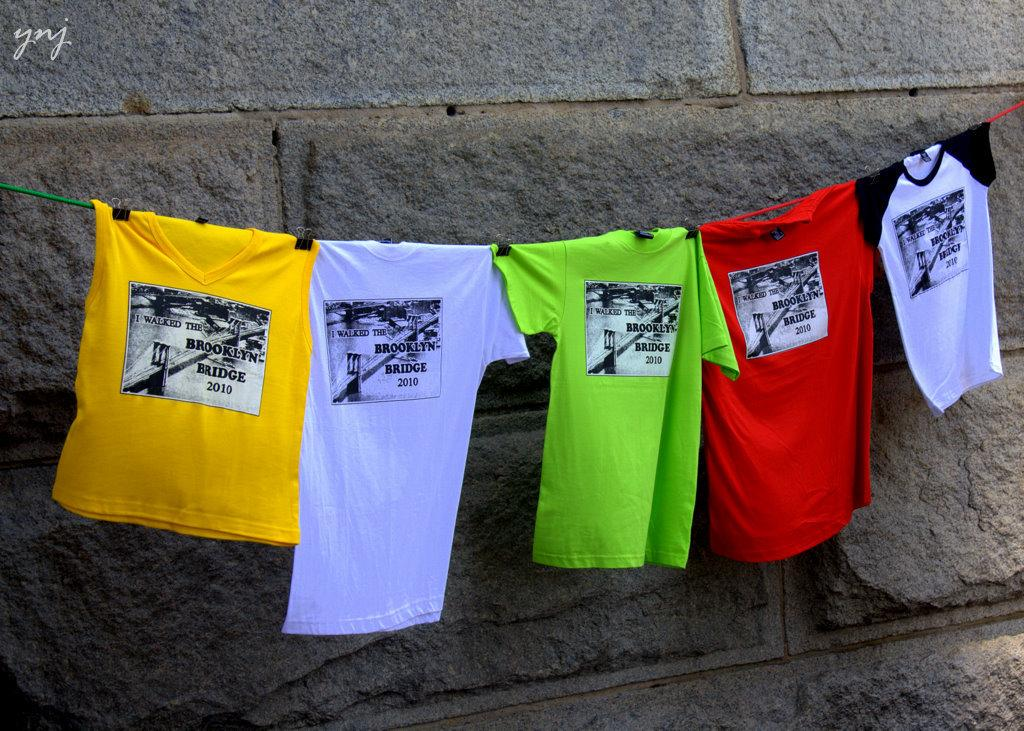<image>
Offer a succinct explanation of the picture presented. A collection of t-shirts that commemorate walking across the Brooklyn bridge. 